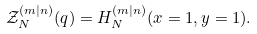<formula> <loc_0><loc_0><loc_500><loc_500>\mathcal { Z } _ { N } ^ { ( m | n ) } ( q ) = H _ { N } ^ { ( m | n ) } ( x = 1 , y = 1 ) .</formula> 